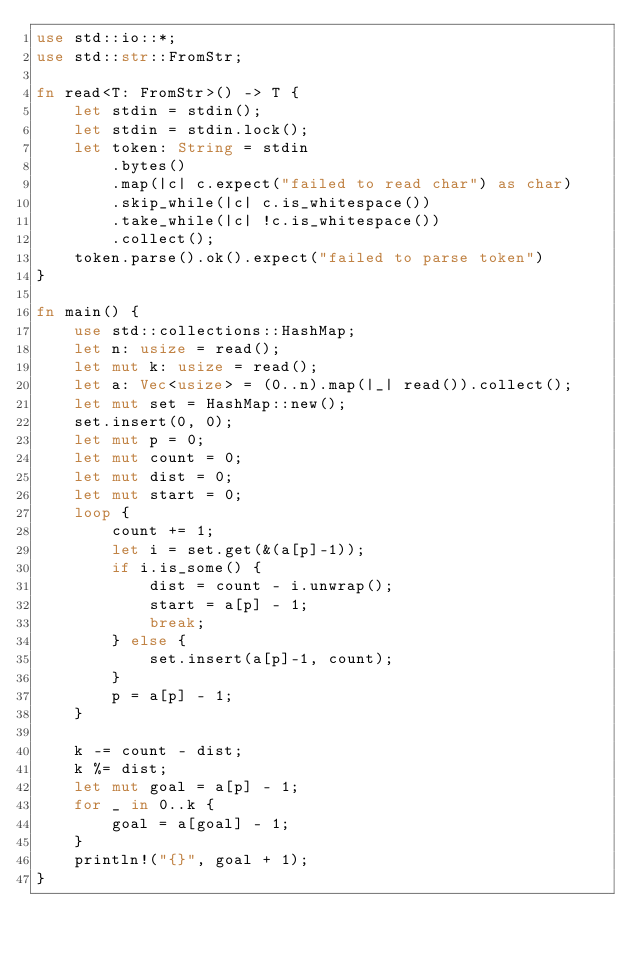Convert code to text. <code><loc_0><loc_0><loc_500><loc_500><_Rust_>use std::io::*;
use std::str::FromStr;

fn read<T: FromStr>() -> T {
    let stdin = stdin();
    let stdin = stdin.lock();
    let token: String = stdin
        .bytes()
        .map(|c| c.expect("failed to read char") as char) 
        .skip_while(|c| c.is_whitespace())
        .take_while(|c| !c.is_whitespace())
        .collect();
    token.parse().ok().expect("failed to parse token")
}

fn main() {
    use std::collections::HashMap;
    let n: usize = read();
    let mut k: usize = read();
    let a: Vec<usize> = (0..n).map(|_| read()).collect();
    let mut set = HashMap::new();
    set.insert(0, 0);
    let mut p = 0;
    let mut count = 0;
    let mut dist = 0;
    let mut start = 0;
    loop {
        count += 1;
        let i = set.get(&(a[p]-1));
        if i.is_some() {
            dist = count - i.unwrap();
            start = a[p] - 1;
            break;
        } else {
            set.insert(a[p]-1, count);
        }
        p = a[p] - 1;
    }

    k -= count - dist;
    k %= dist;
    let mut goal = a[p] - 1;
    for _ in 0..k {
        goal = a[goal] - 1;
    }
    println!("{}", goal + 1);
}
</code> 